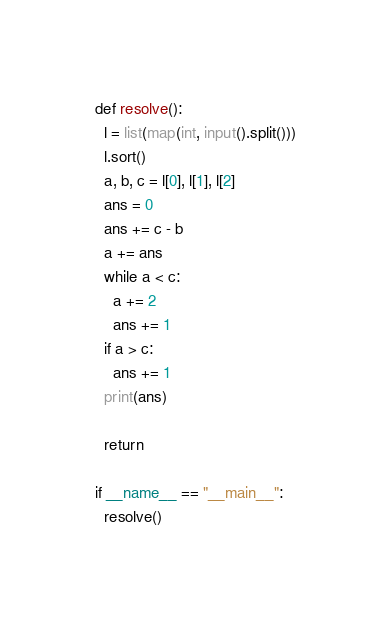Convert code to text. <code><loc_0><loc_0><loc_500><loc_500><_Python_>def resolve():
  l = list(map(int, input().split()))
  l.sort()
  a, b, c = l[0], l[1], l[2]
  ans = 0
  ans += c - b
  a += ans
  while a < c:
    a += 2
    ans += 1
  if a > c:
    ans += 1
  print(ans)

  return

if __name__ == "__main__":
  resolve()
</code> 